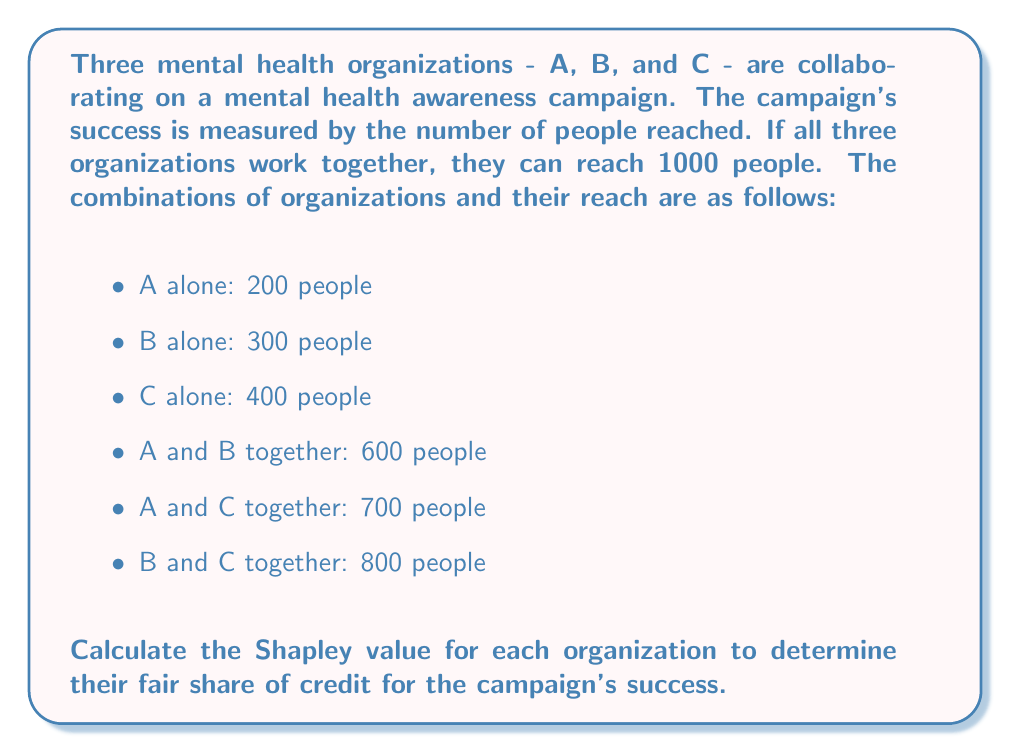Could you help me with this problem? To calculate the Shapley value, we need to consider all possible coalitions and the marginal contributions of each organization. The Shapley value is given by the formula:

$$ \phi_i(v) = \sum_{S \subseteq N \setminus \{i\}} \frac{|S|!(n-|S|-1)!}{n!}[v(S \cup \{i\}) - v(S)] $$

Where:
- $\phi_i(v)$ is the Shapley value for organization $i$
- $N$ is the set of all organizations
- $S$ is a subset of $N$ not containing $i$
- $n$ is the total number of organizations
- $v(S)$ is the value of coalition $S$

Step 1: Calculate marginal contributions for each organization in all possible orders.

1. A, B, C: A = 200, B = 400, C = 400
2. A, C, B: A = 200, C = 500, B = 300
3. B, A, C: B = 300, A = 300, C = 400
4. B, C, A: B = 300, C = 500, A = 200
5. C, A, B: C = 400, A = 300, B = 300
6. C, B, A: C = 400, B = 400, A = 200

Step 2: Calculate the average marginal contribution for each organization.

Organization A: $(200 + 200 + 300 + 200 + 300 + 200) \div 6 = 233.33$
Organization B: $(400 + 300 + 300 + 300 + 300 + 400) \div 6 = 333.33$
Organization C: $(400 + 500 + 400 + 500 + 400 + 400) \div 6 = 433.33$

Step 3: Verify that the sum of Shapley values equals the total value of the grand coalition (1000).

$233.33 + 333.33 + 433.33 = 999.99$ (rounding error)

Therefore, the Shapley values for organizations A, B, and C are approximately 233.33, 333.33, and 433.33, respectively.
Answer: The Shapley values for the organizations are:

Organization A: 233.33
Organization B: 333.33
Organization C: 433.33 